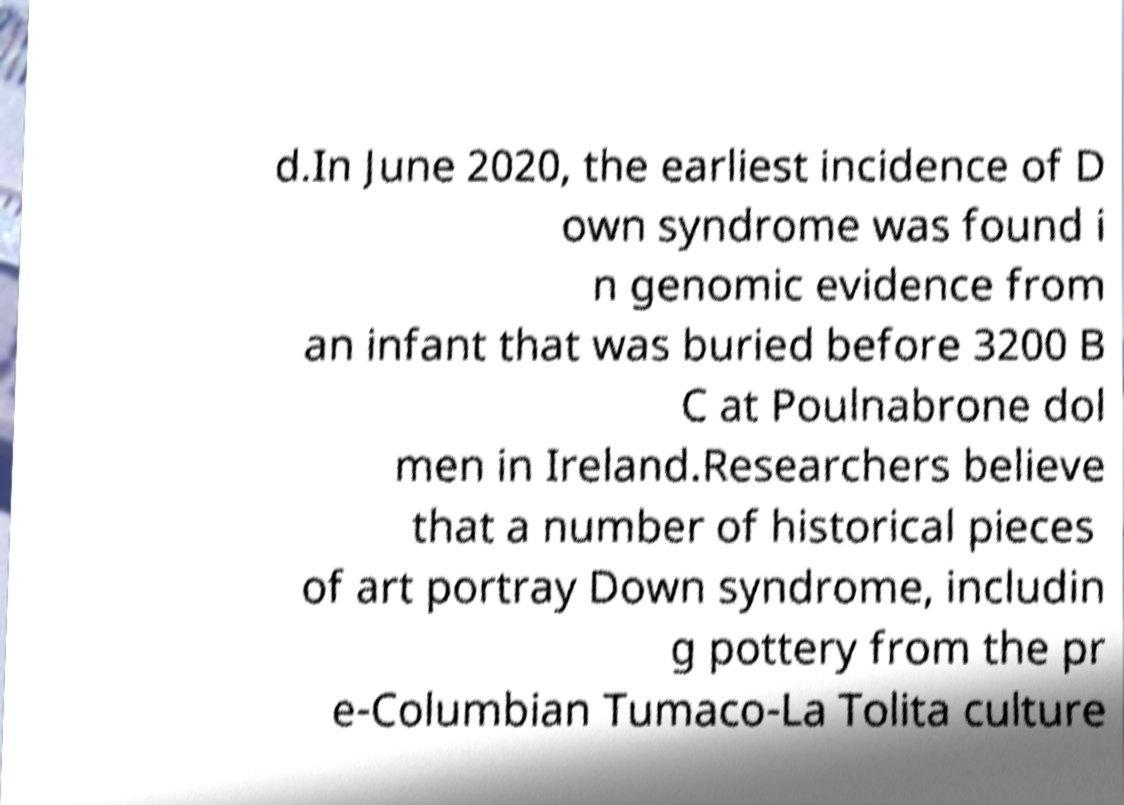Could you assist in decoding the text presented in this image and type it out clearly? d.In June 2020, the earliest incidence of D own syndrome was found i n genomic evidence from an infant that was buried before 3200 B C at Poulnabrone dol men in Ireland.Researchers believe that a number of historical pieces of art portray Down syndrome, includin g pottery from the pr e-Columbian Tumaco-La Tolita culture 